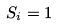<formula> <loc_0><loc_0><loc_500><loc_500>S _ { i } = 1</formula> 